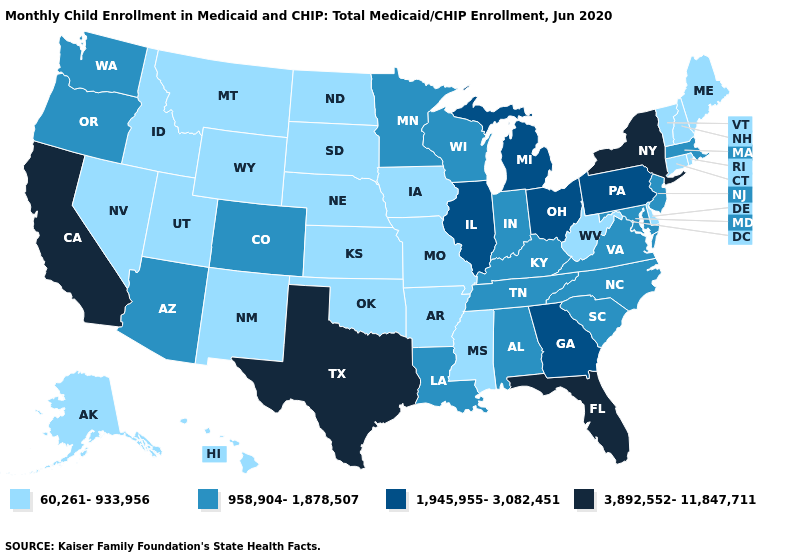What is the value of Texas?
Quick response, please. 3,892,552-11,847,711. Name the states that have a value in the range 3,892,552-11,847,711?
Give a very brief answer. California, Florida, New York, Texas. What is the value of Alaska?
Concise answer only. 60,261-933,956. Does the first symbol in the legend represent the smallest category?
Short answer required. Yes. Is the legend a continuous bar?
Quick response, please. No. What is the highest value in the USA?
Give a very brief answer. 3,892,552-11,847,711. Does New Hampshire have the lowest value in the USA?
Short answer required. Yes. What is the value of Vermont?
Give a very brief answer. 60,261-933,956. What is the value of Florida?
Concise answer only. 3,892,552-11,847,711. Is the legend a continuous bar?
Give a very brief answer. No. Does Maryland have the highest value in the USA?
Be succinct. No. Is the legend a continuous bar?
Quick response, please. No. Does the first symbol in the legend represent the smallest category?
Quick response, please. Yes. Does Texas have the highest value in the USA?
Quick response, please. Yes. Name the states that have a value in the range 3,892,552-11,847,711?
Quick response, please. California, Florida, New York, Texas. 